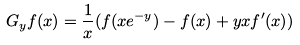<formula> <loc_0><loc_0><loc_500><loc_500>G _ { y } f ( x ) = \frac { 1 } { x } ( f ( x e ^ { - y } ) - f ( x ) + y x f ^ { \prime } ( x ) )</formula> 